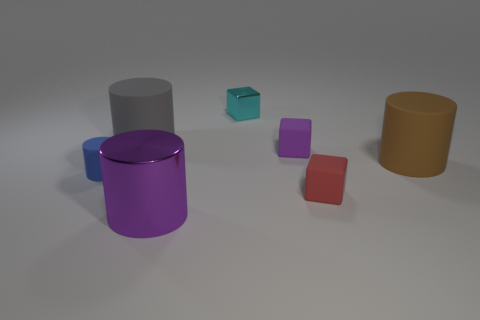Subtract all yellow cylinders. Subtract all yellow spheres. How many cylinders are left? 4 Add 1 big gray cylinders. How many objects exist? 8 Subtract all cylinders. How many objects are left? 3 Subtract all small green cylinders. Subtract all blue objects. How many objects are left? 6 Add 2 cyan metal things. How many cyan metal things are left? 3 Add 1 gray things. How many gray things exist? 2 Subtract 0 yellow cubes. How many objects are left? 7 